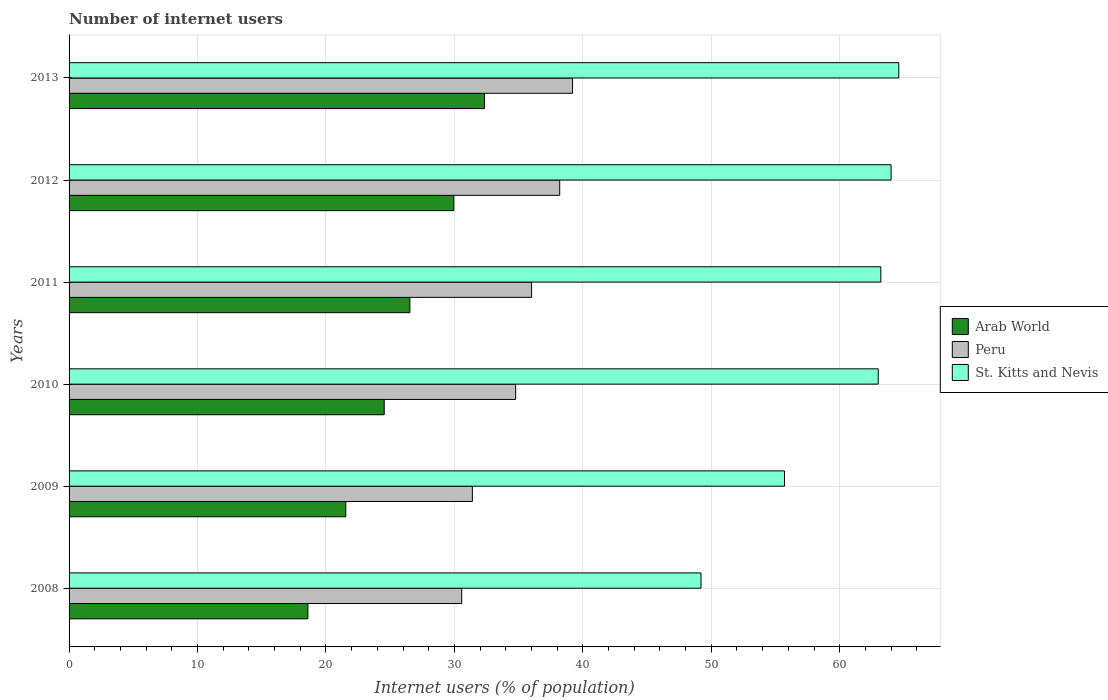Are the number of bars on each tick of the Y-axis equal?
Ensure brevity in your answer.  Yes. How many bars are there on the 1st tick from the top?
Offer a very short reply. 3. How many bars are there on the 2nd tick from the bottom?
Provide a short and direct response. 3. What is the number of internet users in St. Kitts and Nevis in 2009?
Offer a terse response. 55.7. Across all years, what is the maximum number of internet users in Peru?
Offer a terse response. 39.2. Across all years, what is the minimum number of internet users in St. Kitts and Nevis?
Your answer should be very brief. 49.2. In which year was the number of internet users in St. Kitts and Nevis maximum?
Keep it short and to the point. 2013. In which year was the number of internet users in Peru minimum?
Give a very brief answer. 2008. What is the total number of internet users in Arab World in the graph?
Make the answer very short. 153.51. What is the difference between the number of internet users in Arab World in 2009 and that in 2011?
Offer a very short reply. -4.99. What is the difference between the number of internet users in St. Kitts and Nevis in 2008 and the number of internet users in Arab World in 2012?
Offer a very short reply. 19.25. What is the average number of internet users in Peru per year?
Offer a terse response. 35.02. In the year 2009, what is the difference between the number of internet users in Peru and number of internet users in Arab World?
Your answer should be very brief. 9.85. What is the ratio of the number of internet users in Peru in 2009 to that in 2013?
Provide a succinct answer. 0.8. What is the difference between the highest and the second highest number of internet users in St. Kitts and Nevis?
Make the answer very short. 0.6. What is the difference between the highest and the lowest number of internet users in Peru?
Provide a succinct answer. 8.63. What does the 1st bar from the top in 2013 represents?
Keep it short and to the point. St. Kitts and Nevis. What does the 1st bar from the bottom in 2013 represents?
Keep it short and to the point. Arab World. How many bars are there?
Keep it short and to the point. 18. Are all the bars in the graph horizontal?
Offer a terse response. Yes. How many years are there in the graph?
Keep it short and to the point. 6. Does the graph contain any zero values?
Your answer should be compact. No. Does the graph contain grids?
Provide a short and direct response. Yes. Where does the legend appear in the graph?
Keep it short and to the point. Center right. How many legend labels are there?
Your answer should be compact. 3. What is the title of the graph?
Your answer should be compact. Number of internet users. Does "Greece" appear as one of the legend labels in the graph?
Make the answer very short. No. What is the label or title of the X-axis?
Keep it short and to the point. Internet users (% of population). What is the Internet users (% of population) in Arab World in 2008?
Provide a succinct answer. 18.59. What is the Internet users (% of population) in Peru in 2008?
Keep it short and to the point. 30.57. What is the Internet users (% of population) of St. Kitts and Nevis in 2008?
Offer a terse response. 49.2. What is the Internet users (% of population) of Arab World in 2009?
Offer a terse response. 21.55. What is the Internet users (% of population) of Peru in 2009?
Your answer should be compact. 31.4. What is the Internet users (% of population) in St. Kitts and Nevis in 2009?
Provide a short and direct response. 55.7. What is the Internet users (% of population) in Arab World in 2010?
Your answer should be very brief. 24.54. What is the Internet users (% of population) of Peru in 2010?
Give a very brief answer. 34.77. What is the Internet users (% of population) in Arab World in 2011?
Provide a succinct answer. 26.53. What is the Internet users (% of population) in Peru in 2011?
Keep it short and to the point. 36.01. What is the Internet users (% of population) in St. Kitts and Nevis in 2011?
Make the answer very short. 63.2. What is the Internet users (% of population) in Arab World in 2012?
Your response must be concise. 29.95. What is the Internet users (% of population) of Peru in 2012?
Your answer should be very brief. 38.2. What is the Internet users (% of population) of St. Kitts and Nevis in 2012?
Provide a succinct answer. 64. What is the Internet users (% of population) in Arab World in 2013?
Make the answer very short. 32.34. What is the Internet users (% of population) of Peru in 2013?
Your response must be concise. 39.2. What is the Internet users (% of population) of St. Kitts and Nevis in 2013?
Your answer should be compact. 64.6. Across all years, what is the maximum Internet users (% of population) in Arab World?
Your answer should be very brief. 32.34. Across all years, what is the maximum Internet users (% of population) of Peru?
Your answer should be very brief. 39.2. Across all years, what is the maximum Internet users (% of population) of St. Kitts and Nevis?
Make the answer very short. 64.6. Across all years, what is the minimum Internet users (% of population) of Arab World?
Your answer should be compact. 18.59. Across all years, what is the minimum Internet users (% of population) in Peru?
Make the answer very short. 30.57. Across all years, what is the minimum Internet users (% of population) in St. Kitts and Nevis?
Provide a succinct answer. 49.2. What is the total Internet users (% of population) in Arab World in the graph?
Your response must be concise. 153.5. What is the total Internet users (% of population) of Peru in the graph?
Your answer should be compact. 210.15. What is the total Internet users (% of population) of St. Kitts and Nevis in the graph?
Make the answer very short. 359.7. What is the difference between the Internet users (% of population) in Arab World in 2008 and that in 2009?
Offer a terse response. -2.95. What is the difference between the Internet users (% of population) in Peru in 2008 and that in 2009?
Offer a very short reply. -0.83. What is the difference between the Internet users (% of population) of St. Kitts and Nevis in 2008 and that in 2009?
Offer a terse response. -6.5. What is the difference between the Internet users (% of population) of Arab World in 2008 and that in 2010?
Your response must be concise. -5.94. What is the difference between the Internet users (% of population) in Arab World in 2008 and that in 2011?
Keep it short and to the point. -7.94. What is the difference between the Internet users (% of population) in Peru in 2008 and that in 2011?
Provide a short and direct response. -5.44. What is the difference between the Internet users (% of population) of St. Kitts and Nevis in 2008 and that in 2011?
Make the answer very short. -14. What is the difference between the Internet users (% of population) in Arab World in 2008 and that in 2012?
Ensure brevity in your answer.  -11.36. What is the difference between the Internet users (% of population) in Peru in 2008 and that in 2012?
Provide a short and direct response. -7.63. What is the difference between the Internet users (% of population) of St. Kitts and Nevis in 2008 and that in 2012?
Give a very brief answer. -14.8. What is the difference between the Internet users (% of population) in Arab World in 2008 and that in 2013?
Provide a succinct answer. -13.75. What is the difference between the Internet users (% of population) of Peru in 2008 and that in 2013?
Your answer should be very brief. -8.63. What is the difference between the Internet users (% of population) of St. Kitts and Nevis in 2008 and that in 2013?
Give a very brief answer. -15.4. What is the difference between the Internet users (% of population) of Arab World in 2009 and that in 2010?
Give a very brief answer. -2.99. What is the difference between the Internet users (% of population) of Peru in 2009 and that in 2010?
Keep it short and to the point. -3.37. What is the difference between the Internet users (% of population) of Arab World in 2009 and that in 2011?
Offer a very short reply. -4.99. What is the difference between the Internet users (% of population) in Peru in 2009 and that in 2011?
Ensure brevity in your answer.  -4.61. What is the difference between the Internet users (% of population) of Arab World in 2009 and that in 2012?
Your answer should be compact. -8.41. What is the difference between the Internet users (% of population) in Peru in 2009 and that in 2012?
Provide a succinct answer. -6.8. What is the difference between the Internet users (% of population) in St. Kitts and Nevis in 2009 and that in 2012?
Your answer should be compact. -8.3. What is the difference between the Internet users (% of population) in Arab World in 2009 and that in 2013?
Provide a succinct answer. -10.8. What is the difference between the Internet users (% of population) in Arab World in 2010 and that in 2011?
Ensure brevity in your answer.  -2. What is the difference between the Internet users (% of population) of Peru in 2010 and that in 2011?
Your answer should be compact. -1.24. What is the difference between the Internet users (% of population) of Arab World in 2010 and that in 2012?
Your answer should be compact. -5.42. What is the difference between the Internet users (% of population) in Peru in 2010 and that in 2012?
Give a very brief answer. -3.43. What is the difference between the Internet users (% of population) in St. Kitts and Nevis in 2010 and that in 2012?
Give a very brief answer. -1. What is the difference between the Internet users (% of population) of Arab World in 2010 and that in 2013?
Your answer should be very brief. -7.81. What is the difference between the Internet users (% of population) of Peru in 2010 and that in 2013?
Offer a terse response. -4.43. What is the difference between the Internet users (% of population) in St. Kitts and Nevis in 2010 and that in 2013?
Make the answer very short. -1.6. What is the difference between the Internet users (% of population) of Arab World in 2011 and that in 2012?
Keep it short and to the point. -3.42. What is the difference between the Internet users (% of population) in Peru in 2011 and that in 2012?
Give a very brief answer. -2.19. What is the difference between the Internet users (% of population) in St. Kitts and Nevis in 2011 and that in 2012?
Offer a very short reply. -0.8. What is the difference between the Internet users (% of population) in Arab World in 2011 and that in 2013?
Your answer should be very brief. -5.81. What is the difference between the Internet users (% of population) in Peru in 2011 and that in 2013?
Keep it short and to the point. -3.19. What is the difference between the Internet users (% of population) in Arab World in 2012 and that in 2013?
Give a very brief answer. -2.39. What is the difference between the Internet users (% of population) in Arab World in 2008 and the Internet users (% of population) in Peru in 2009?
Your answer should be very brief. -12.81. What is the difference between the Internet users (% of population) in Arab World in 2008 and the Internet users (% of population) in St. Kitts and Nevis in 2009?
Your response must be concise. -37.11. What is the difference between the Internet users (% of population) in Peru in 2008 and the Internet users (% of population) in St. Kitts and Nevis in 2009?
Give a very brief answer. -25.13. What is the difference between the Internet users (% of population) of Arab World in 2008 and the Internet users (% of population) of Peru in 2010?
Make the answer very short. -16.18. What is the difference between the Internet users (% of population) of Arab World in 2008 and the Internet users (% of population) of St. Kitts and Nevis in 2010?
Provide a short and direct response. -44.41. What is the difference between the Internet users (% of population) in Peru in 2008 and the Internet users (% of population) in St. Kitts and Nevis in 2010?
Provide a short and direct response. -32.43. What is the difference between the Internet users (% of population) of Arab World in 2008 and the Internet users (% of population) of Peru in 2011?
Make the answer very short. -17.42. What is the difference between the Internet users (% of population) of Arab World in 2008 and the Internet users (% of population) of St. Kitts and Nevis in 2011?
Give a very brief answer. -44.61. What is the difference between the Internet users (% of population) of Peru in 2008 and the Internet users (% of population) of St. Kitts and Nevis in 2011?
Offer a terse response. -32.63. What is the difference between the Internet users (% of population) of Arab World in 2008 and the Internet users (% of population) of Peru in 2012?
Ensure brevity in your answer.  -19.61. What is the difference between the Internet users (% of population) in Arab World in 2008 and the Internet users (% of population) in St. Kitts and Nevis in 2012?
Ensure brevity in your answer.  -45.41. What is the difference between the Internet users (% of population) of Peru in 2008 and the Internet users (% of population) of St. Kitts and Nevis in 2012?
Ensure brevity in your answer.  -33.43. What is the difference between the Internet users (% of population) in Arab World in 2008 and the Internet users (% of population) in Peru in 2013?
Offer a terse response. -20.61. What is the difference between the Internet users (% of population) of Arab World in 2008 and the Internet users (% of population) of St. Kitts and Nevis in 2013?
Your answer should be very brief. -46.01. What is the difference between the Internet users (% of population) of Peru in 2008 and the Internet users (% of population) of St. Kitts and Nevis in 2013?
Give a very brief answer. -34.03. What is the difference between the Internet users (% of population) of Arab World in 2009 and the Internet users (% of population) of Peru in 2010?
Ensure brevity in your answer.  -13.22. What is the difference between the Internet users (% of population) of Arab World in 2009 and the Internet users (% of population) of St. Kitts and Nevis in 2010?
Your response must be concise. -41.45. What is the difference between the Internet users (% of population) in Peru in 2009 and the Internet users (% of population) in St. Kitts and Nevis in 2010?
Give a very brief answer. -31.6. What is the difference between the Internet users (% of population) of Arab World in 2009 and the Internet users (% of population) of Peru in 2011?
Give a very brief answer. -14.46. What is the difference between the Internet users (% of population) in Arab World in 2009 and the Internet users (% of population) in St. Kitts and Nevis in 2011?
Your answer should be very brief. -41.65. What is the difference between the Internet users (% of population) in Peru in 2009 and the Internet users (% of population) in St. Kitts and Nevis in 2011?
Offer a very short reply. -31.8. What is the difference between the Internet users (% of population) in Arab World in 2009 and the Internet users (% of population) in Peru in 2012?
Your answer should be compact. -16.65. What is the difference between the Internet users (% of population) in Arab World in 2009 and the Internet users (% of population) in St. Kitts and Nevis in 2012?
Keep it short and to the point. -42.45. What is the difference between the Internet users (% of population) of Peru in 2009 and the Internet users (% of population) of St. Kitts and Nevis in 2012?
Give a very brief answer. -32.6. What is the difference between the Internet users (% of population) in Arab World in 2009 and the Internet users (% of population) in Peru in 2013?
Offer a terse response. -17.65. What is the difference between the Internet users (% of population) in Arab World in 2009 and the Internet users (% of population) in St. Kitts and Nevis in 2013?
Provide a short and direct response. -43.05. What is the difference between the Internet users (% of population) of Peru in 2009 and the Internet users (% of population) of St. Kitts and Nevis in 2013?
Your response must be concise. -33.2. What is the difference between the Internet users (% of population) in Arab World in 2010 and the Internet users (% of population) in Peru in 2011?
Your answer should be compact. -11.47. What is the difference between the Internet users (% of population) of Arab World in 2010 and the Internet users (% of population) of St. Kitts and Nevis in 2011?
Ensure brevity in your answer.  -38.66. What is the difference between the Internet users (% of population) of Peru in 2010 and the Internet users (% of population) of St. Kitts and Nevis in 2011?
Your answer should be very brief. -28.43. What is the difference between the Internet users (% of population) in Arab World in 2010 and the Internet users (% of population) in Peru in 2012?
Your answer should be very brief. -13.66. What is the difference between the Internet users (% of population) of Arab World in 2010 and the Internet users (% of population) of St. Kitts and Nevis in 2012?
Offer a terse response. -39.46. What is the difference between the Internet users (% of population) in Peru in 2010 and the Internet users (% of population) in St. Kitts and Nevis in 2012?
Offer a terse response. -29.23. What is the difference between the Internet users (% of population) of Arab World in 2010 and the Internet users (% of population) of Peru in 2013?
Provide a short and direct response. -14.66. What is the difference between the Internet users (% of population) of Arab World in 2010 and the Internet users (% of population) of St. Kitts and Nevis in 2013?
Offer a very short reply. -40.06. What is the difference between the Internet users (% of population) in Peru in 2010 and the Internet users (% of population) in St. Kitts and Nevis in 2013?
Offer a terse response. -29.83. What is the difference between the Internet users (% of population) of Arab World in 2011 and the Internet users (% of population) of Peru in 2012?
Offer a very short reply. -11.67. What is the difference between the Internet users (% of population) of Arab World in 2011 and the Internet users (% of population) of St. Kitts and Nevis in 2012?
Provide a succinct answer. -37.47. What is the difference between the Internet users (% of population) in Peru in 2011 and the Internet users (% of population) in St. Kitts and Nevis in 2012?
Keep it short and to the point. -27.99. What is the difference between the Internet users (% of population) of Arab World in 2011 and the Internet users (% of population) of Peru in 2013?
Give a very brief answer. -12.67. What is the difference between the Internet users (% of population) in Arab World in 2011 and the Internet users (% of population) in St. Kitts and Nevis in 2013?
Make the answer very short. -38.07. What is the difference between the Internet users (% of population) in Peru in 2011 and the Internet users (% of population) in St. Kitts and Nevis in 2013?
Your answer should be compact. -28.59. What is the difference between the Internet users (% of population) of Arab World in 2012 and the Internet users (% of population) of Peru in 2013?
Your response must be concise. -9.25. What is the difference between the Internet users (% of population) in Arab World in 2012 and the Internet users (% of population) in St. Kitts and Nevis in 2013?
Your answer should be very brief. -34.65. What is the difference between the Internet users (% of population) in Peru in 2012 and the Internet users (% of population) in St. Kitts and Nevis in 2013?
Ensure brevity in your answer.  -26.4. What is the average Internet users (% of population) of Arab World per year?
Your answer should be compact. 25.58. What is the average Internet users (% of population) in Peru per year?
Make the answer very short. 35.02. What is the average Internet users (% of population) in St. Kitts and Nevis per year?
Provide a succinct answer. 59.95. In the year 2008, what is the difference between the Internet users (% of population) in Arab World and Internet users (% of population) in Peru?
Offer a very short reply. -11.98. In the year 2008, what is the difference between the Internet users (% of population) of Arab World and Internet users (% of population) of St. Kitts and Nevis?
Offer a very short reply. -30.61. In the year 2008, what is the difference between the Internet users (% of population) in Peru and Internet users (% of population) in St. Kitts and Nevis?
Your answer should be very brief. -18.63. In the year 2009, what is the difference between the Internet users (% of population) of Arab World and Internet users (% of population) of Peru?
Offer a terse response. -9.85. In the year 2009, what is the difference between the Internet users (% of population) of Arab World and Internet users (% of population) of St. Kitts and Nevis?
Give a very brief answer. -34.15. In the year 2009, what is the difference between the Internet users (% of population) of Peru and Internet users (% of population) of St. Kitts and Nevis?
Offer a very short reply. -24.3. In the year 2010, what is the difference between the Internet users (% of population) of Arab World and Internet users (% of population) of Peru?
Ensure brevity in your answer.  -10.23. In the year 2010, what is the difference between the Internet users (% of population) of Arab World and Internet users (% of population) of St. Kitts and Nevis?
Offer a very short reply. -38.46. In the year 2010, what is the difference between the Internet users (% of population) in Peru and Internet users (% of population) in St. Kitts and Nevis?
Your response must be concise. -28.23. In the year 2011, what is the difference between the Internet users (% of population) of Arab World and Internet users (% of population) of Peru?
Give a very brief answer. -9.48. In the year 2011, what is the difference between the Internet users (% of population) in Arab World and Internet users (% of population) in St. Kitts and Nevis?
Your answer should be compact. -36.67. In the year 2011, what is the difference between the Internet users (% of population) of Peru and Internet users (% of population) of St. Kitts and Nevis?
Keep it short and to the point. -27.19. In the year 2012, what is the difference between the Internet users (% of population) of Arab World and Internet users (% of population) of Peru?
Give a very brief answer. -8.25. In the year 2012, what is the difference between the Internet users (% of population) in Arab World and Internet users (% of population) in St. Kitts and Nevis?
Keep it short and to the point. -34.05. In the year 2012, what is the difference between the Internet users (% of population) of Peru and Internet users (% of population) of St. Kitts and Nevis?
Provide a short and direct response. -25.8. In the year 2013, what is the difference between the Internet users (% of population) of Arab World and Internet users (% of population) of Peru?
Your response must be concise. -6.86. In the year 2013, what is the difference between the Internet users (% of population) in Arab World and Internet users (% of population) in St. Kitts and Nevis?
Keep it short and to the point. -32.26. In the year 2013, what is the difference between the Internet users (% of population) in Peru and Internet users (% of population) in St. Kitts and Nevis?
Keep it short and to the point. -25.4. What is the ratio of the Internet users (% of population) in Arab World in 2008 to that in 2009?
Your answer should be very brief. 0.86. What is the ratio of the Internet users (% of population) in Peru in 2008 to that in 2009?
Your answer should be very brief. 0.97. What is the ratio of the Internet users (% of population) of St. Kitts and Nevis in 2008 to that in 2009?
Your answer should be very brief. 0.88. What is the ratio of the Internet users (% of population) in Arab World in 2008 to that in 2010?
Offer a terse response. 0.76. What is the ratio of the Internet users (% of population) of Peru in 2008 to that in 2010?
Give a very brief answer. 0.88. What is the ratio of the Internet users (% of population) in St. Kitts and Nevis in 2008 to that in 2010?
Offer a terse response. 0.78. What is the ratio of the Internet users (% of population) of Arab World in 2008 to that in 2011?
Your answer should be very brief. 0.7. What is the ratio of the Internet users (% of population) of Peru in 2008 to that in 2011?
Offer a very short reply. 0.85. What is the ratio of the Internet users (% of population) in St. Kitts and Nevis in 2008 to that in 2011?
Make the answer very short. 0.78. What is the ratio of the Internet users (% of population) in Arab World in 2008 to that in 2012?
Your answer should be very brief. 0.62. What is the ratio of the Internet users (% of population) of Peru in 2008 to that in 2012?
Your answer should be compact. 0.8. What is the ratio of the Internet users (% of population) of St. Kitts and Nevis in 2008 to that in 2012?
Give a very brief answer. 0.77. What is the ratio of the Internet users (% of population) of Arab World in 2008 to that in 2013?
Your response must be concise. 0.57. What is the ratio of the Internet users (% of population) in Peru in 2008 to that in 2013?
Give a very brief answer. 0.78. What is the ratio of the Internet users (% of population) in St. Kitts and Nevis in 2008 to that in 2013?
Give a very brief answer. 0.76. What is the ratio of the Internet users (% of population) of Arab World in 2009 to that in 2010?
Provide a short and direct response. 0.88. What is the ratio of the Internet users (% of population) of Peru in 2009 to that in 2010?
Make the answer very short. 0.9. What is the ratio of the Internet users (% of population) in St. Kitts and Nevis in 2009 to that in 2010?
Offer a terse response. 0.88. What is the ratio of the Internet users (% of population) of Arab World in 2009 to that in 2011?
Offer a very short reply. 0.81. What is the ratio of the Internet users (% of population) of Peru in 2009 to that in 2011?
Make the answer very short. 0.87. What is the ratio of the Internet users (% of population) of St. Kitts and Nevis in 2009 to that in 2011?
Give a very brief answer. 0.88. What is the ratio of the Internet users (% of population) in Arab World in 2009 to that in 2012?
Offer a very short reply. 0.72. What is the ratio of the Internet users (% of population) in Peru in 2009 to that in 2012?
Make the answer very short. 0.82. What is the ratio of the Internet users (% of population) in St. Kitts and Nevis in 2009 to that in 2012?
Keep it short and to the point. 0.87. What is the ratio of the Internet users (% of population) of Arab World in 2009 to that in 2013?
Offer a terse response. 0.67. What is the ratio of the Internet users (% of population) in Peru in 2009 to that in 2013?
Ensure brevity in your answer.  0.8. What is the ratio of the Internet users (% of population) in St. Kitts and Nevis in 2009 to that in 2013?
Ensure brevity in your answer.  0.86. What is the ratio of the Internet users (% of population) in Arab World in 2010 to that in 2011?
Your response must be concise. 0.92. What is the ratio of the Internet users (% of population) in Peru in 2010 to that in 2011?
Make the answer very short. 0.97. What is the ratio of the Internet users (% of population) of Arab World in 2010 to that in 2012?
Offer a terse response. 0.82. What is the ratio of the Internet users (% of population) in Peru in 2010 to that in 2012?
Your response must be concise. 0.91. What is the ratio of the Internet users (% of population) of St. Kitts and Nevis in 2010 to that in 2012?
Keep it short and to the point. 0.98. What is the ratio of the Internet users (% of population) of Arab World in 2010 to that in 2013?
Offer a very short reply. 0.76. What is the ratio of the Internet users (% of population) of Peru in 2010 to that in 2013?
Ensure brevity in your answer.  0.89. What is the ratio of the Internet users (% of population) in St. Kitts and Nevis in 2010 to that in 2013?
Your response must be concise. 0.98. What is the ratio of the Internet users (% of population) of Arab World in 2011 to that in 2012?
Keep it short and to the point. 0.89. What is the ratio of the Internet users (% of population) in Peru in 2011 to that in 2012?
Give a very brief answer. 0.94. What is the ratio of the Internet users (% of population) in St. Kitts and Nevis in 2011 to that in 2012?
Offer a terse response. 0.99. What is the ratio of the Internet users (% of population) of Arab World in 2011 to that in 2013?
Your answer should be compact. 0.82. What is the ratio of the Internet users (% of population) of Peru in 2011 to that in 2013?
Your response must be concise. 0.92. What is the ratio of the Internet users (% of population) in St. Kitts and Nevis in 2011 to that in 2013?
Your answer should be compact. 0.98. What is the ratio of the Internet users (% of population) in Arab World in 2012 to that in 2013?
Provide a succinct answer. 0.93. What is the ratio of the Internet users (% of population) of Peru in 2012 to that in 2013?
Make the answer very short. 0.97. What is the difference between the highest and the second highest Internet users (% of population) in Arab World?
Give a very brief answer. 2.39. What is the difference between the highest and the second highest Internet users (% of population) of Peru?
Your response must be concise. 1. What is the difference between the highest and the second highest Internet users (% of population) in St. Kitts and Nevis?
Provide a short and direct response. 0.6. What is the difference between the highest and the lowest Internet users (% of population) in Arab World?
Offer a very short reply. 13.75. What is the difference between the highest and the lowest Internet users (% of population) of Peru?
Give a very brief answer. 8.63. What is the difference between the highest and the lowest Internet users (% of population) of St. Kitts and Nevis?
Your answer should be compact. 15.4. 